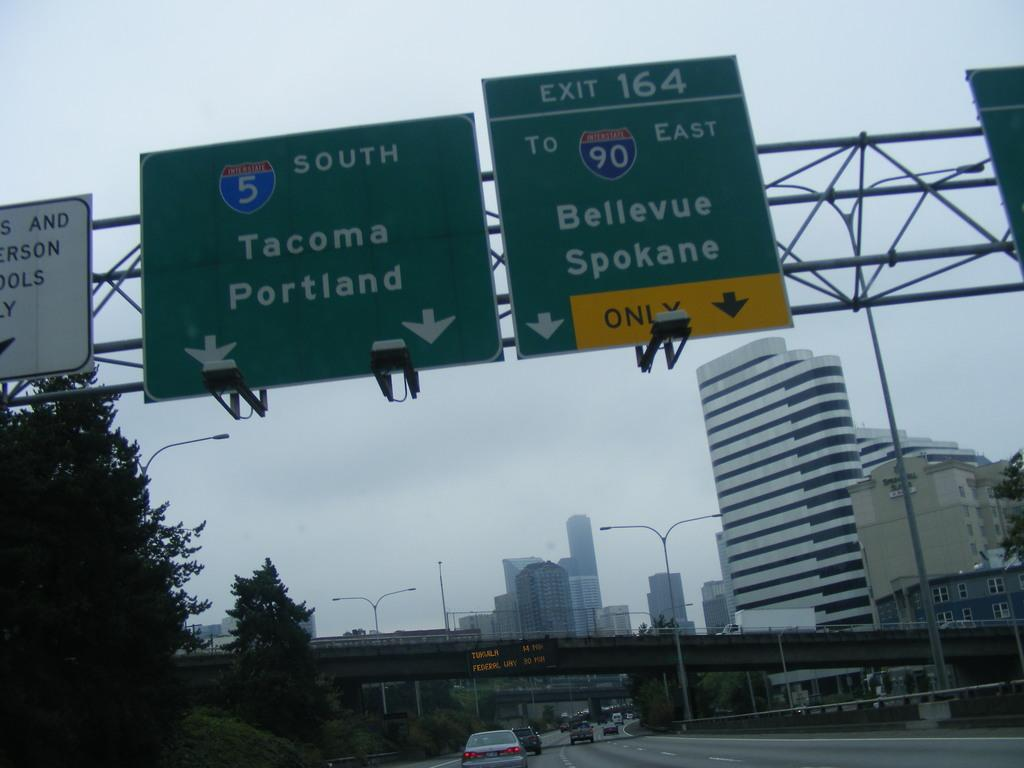<image>
Provide a brief description of the given image. A road sign signifying that Tacoma and Portland are to the south. 